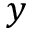<formula> <loc_0><loc_0><loc_500><loc_500>y</formula> 